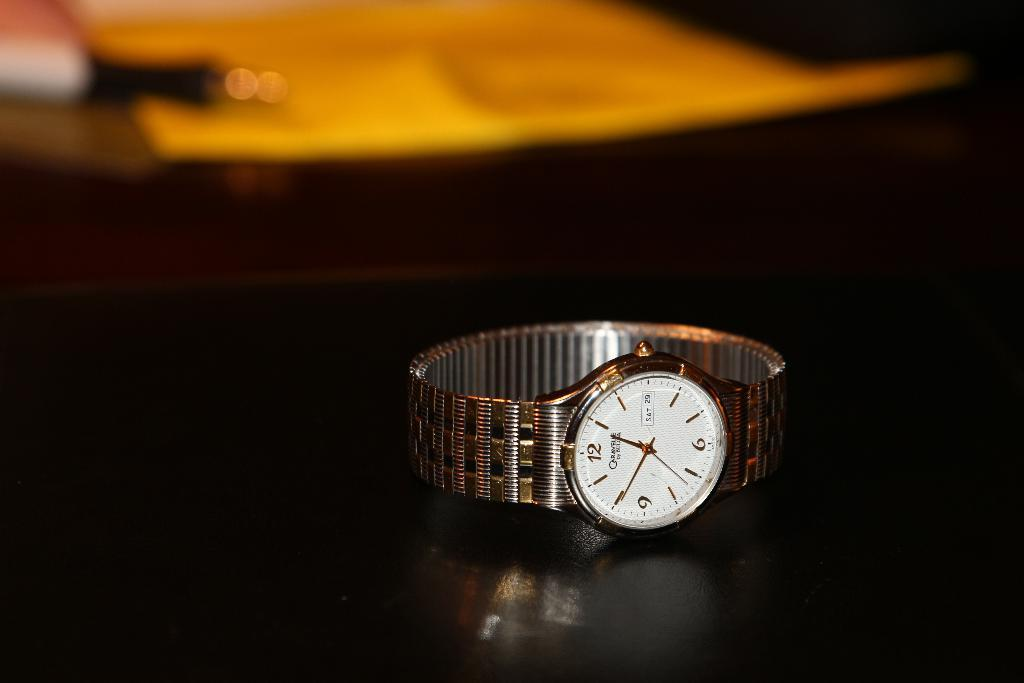<image>
Describe the image concisely. SIlver and white watch with the hands on the number 1 and 10. 